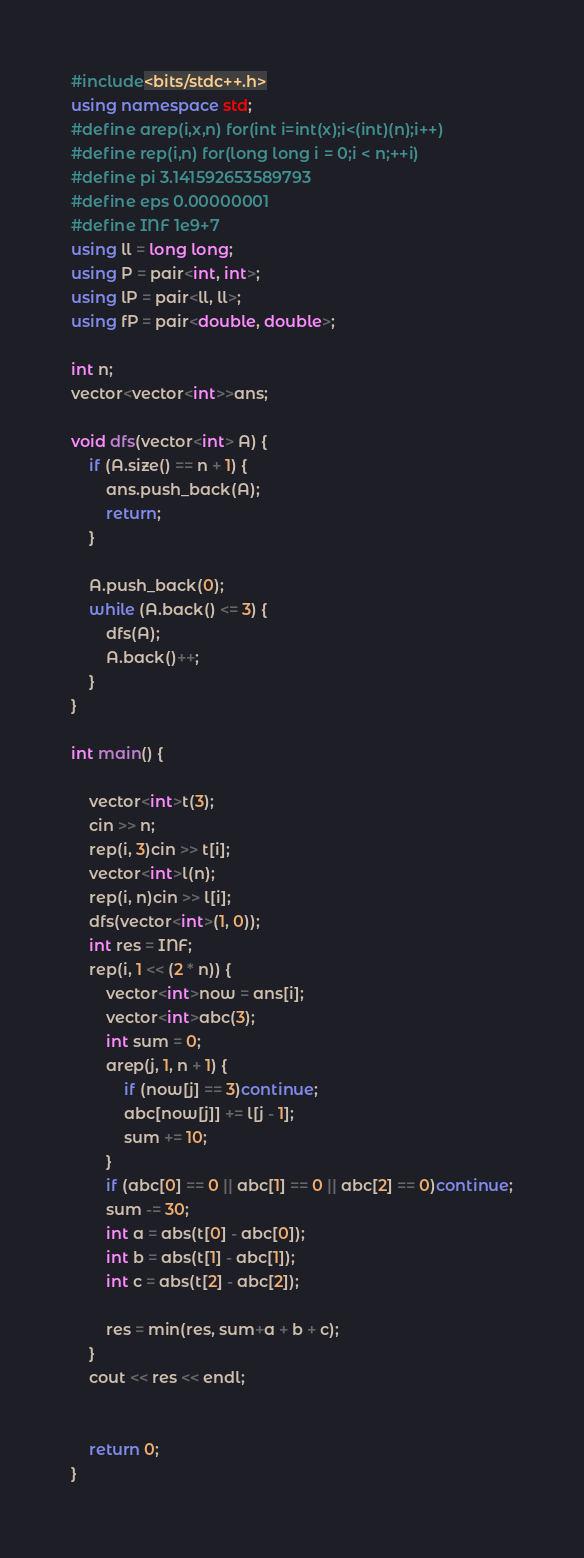Convert code to text. <code><loc_0><loc_0><loc_500><loc_500><_C++_>#include<bits/stdc++.h>
using namespace std;
#define arep(i,x,n) for(int i=int(x);i<(int)(n);i++)
#define rep(i,n) for(long long i = 0;i < n;++i)
#define pi 3.141592653589793
#define eps 0.00000001
#define INF 1e9+7  
using ll = long long;
using P = pair<int, int>;
using lP = pair<ll, ll>;
using fP = pair<double, double>;

int n;
vector<vector<int>>ans;

void dfs(vector<int> A) {
    if (A.size() == n + 1) {
        ans.push_back(A);
        return;
    }

    A.push_back(0);
    while (A.back() <= 3) {
        dfs(A);
        A.back()++;
    }
}

int main() {
    
    vector<int>t(3);
    cin >> n;
    rep(i, 3)cin >> t[i];
    vector<int>l(n);
    rep(i, n)cin >> l[i];
    dfs(vector<int>(1, 0));
    int res = INF;
    rep(i, 1 << (2 * n)) {
        vector<int>now = ans[i];
        vector<int>abc(3);
        int sum = 0;
        arep(j, 1, n + 1) {
            if (now[j] == 3)continue;
            abc[now[j]] += l[j - 1];
            sum += 10;
        }
        if (abc[0] == 0 || abc[1] == 0 || abc[2] == 0)continue;
        sum -= 30;
        int a = abs(t[0] - abc[0]);
        int b = abs(t[1] - abc[1]);
        int c = abs(t[2] - abc[2]);

        res = min(res, sum+a + b + c);
    }
    cout << res << endl;


    return 0;
}</code> 